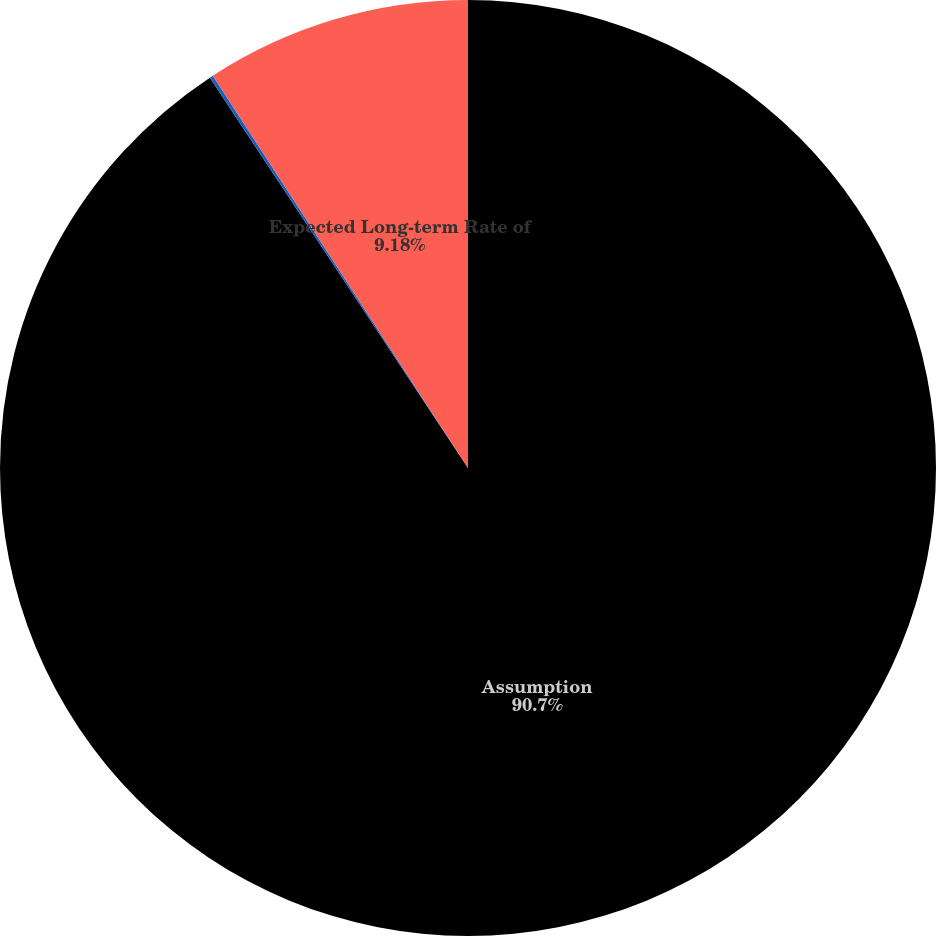Convert chart to OTSL. <chart><loc_0><loc_0><loc_500><loc_500><pie_chart><fcel>Assumption<fcel>Discount Rate<fcel>Expected Long-term Rate of<nl><fcel>90.7%<fcel>0.12%<fcel>9.18%<nl></chart> 